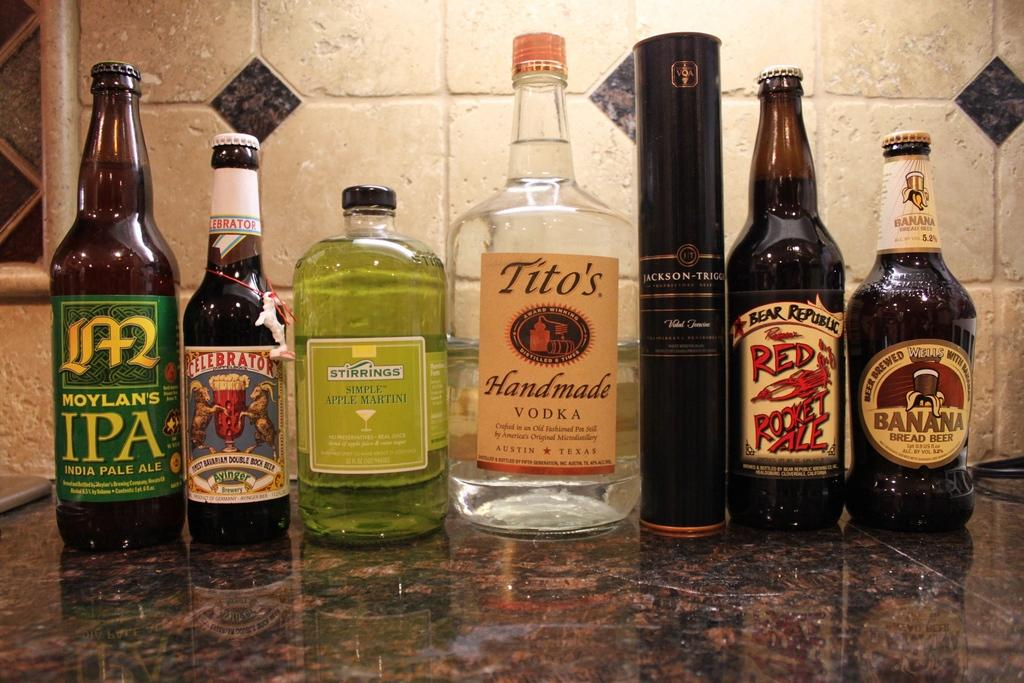<image>
Describe the image concisely. Several bottles of liquor on a countertop including Tito's Handmade Vodka 